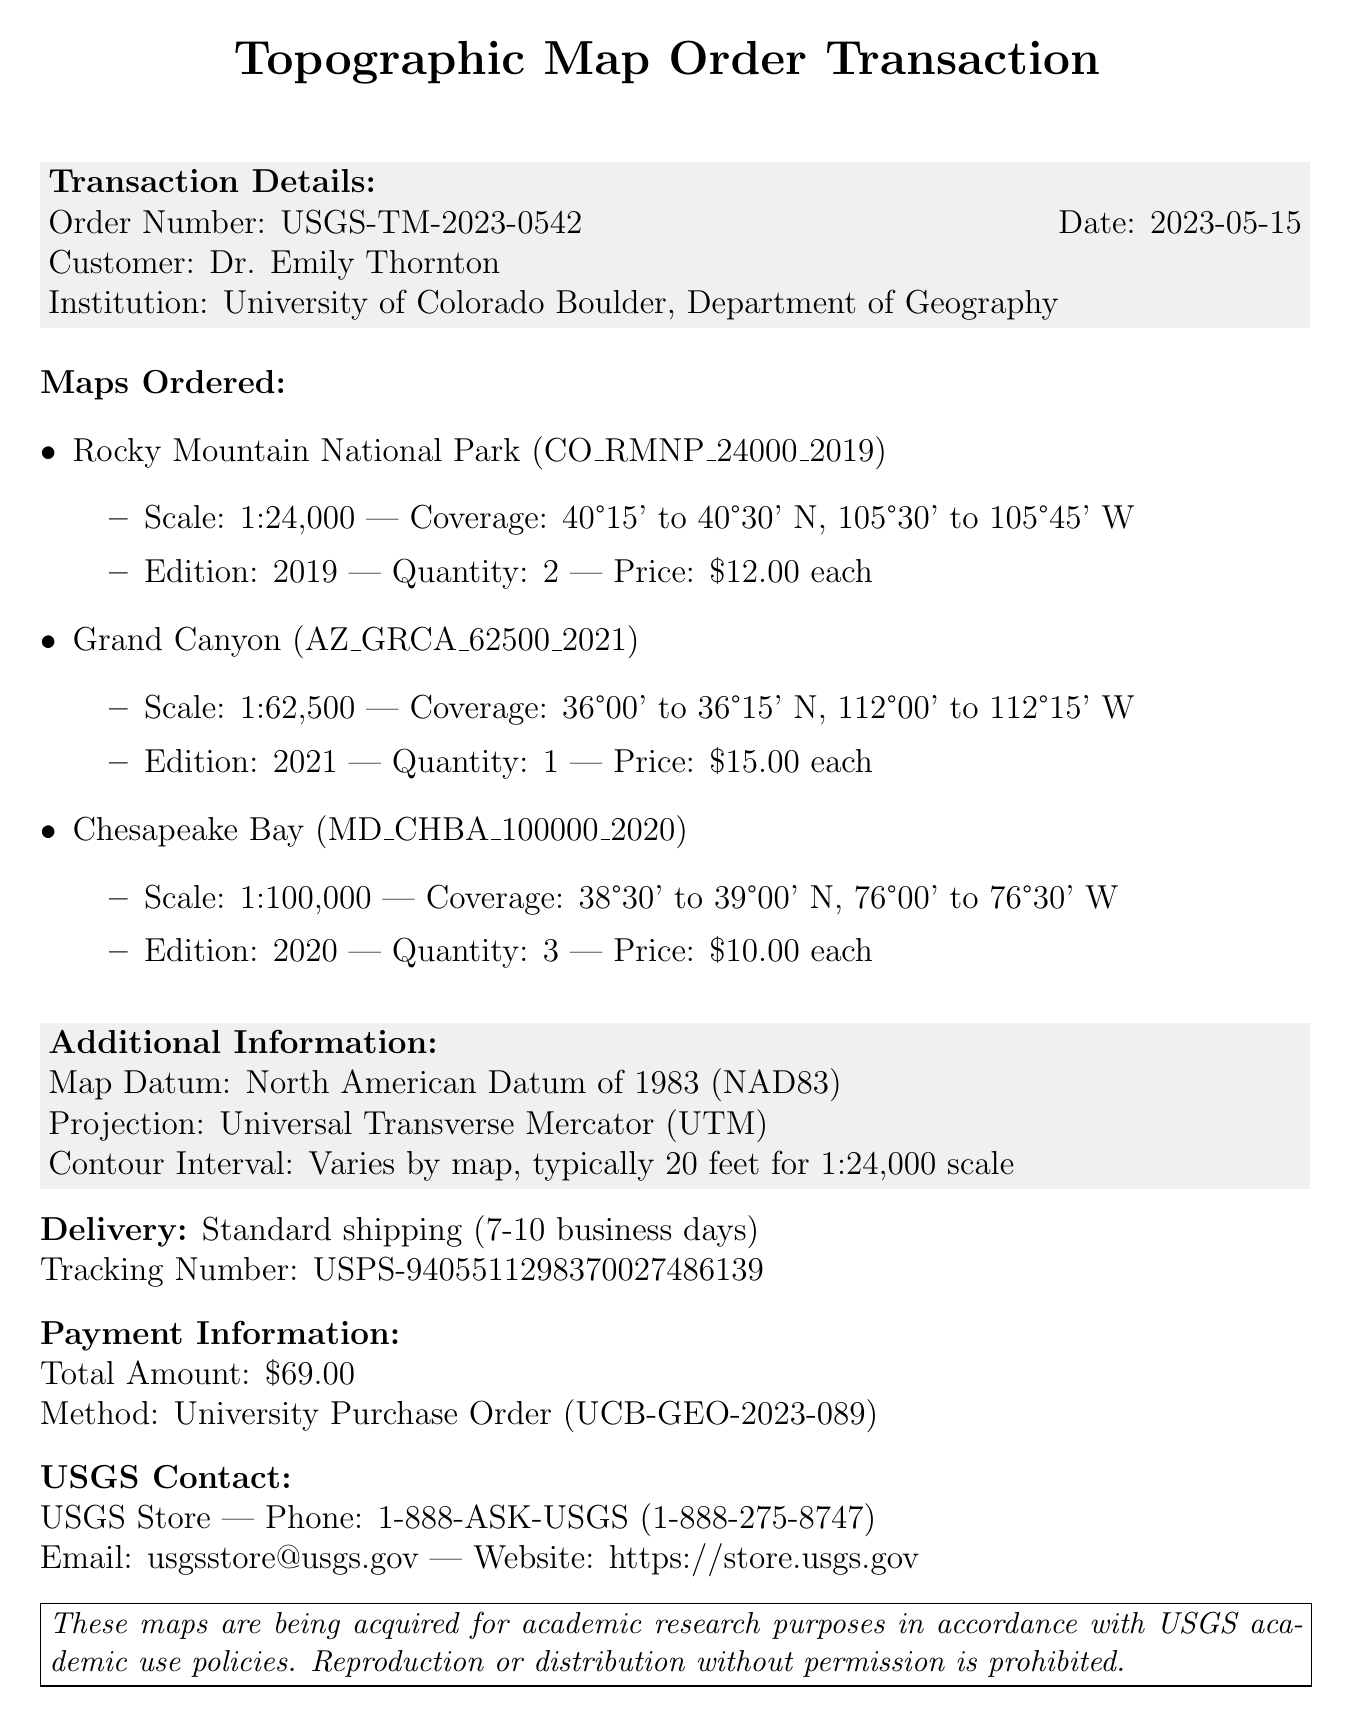What is the order number? The order number is a specific identifier for the transaction, found in the transaction details section.
Answer: USGS-TM-2023-0542 Who is the customer? The customer's name is provided in the transaction details section.
Answer: Dr. Emily Thornton What is the scale of the Chesapeake Bay map? The scale of the Chesapeake Bay map is listed in the details for that specific map.
Answer: 1:100,000 How many maps were ordered in total? The total number of maps can be found by summing the quantity of each map in the order.
Answer: 6 What is the total amount paid for the order? The total amount is specified in the payment information section.
Answer: $69.00 What is the estimated delivery time? The estimated delivery time is mentioned in the delivery method section of the document.
Answer: 7-10 business days What edition is the Grand Canyon map? The edition of the Grand Canyon map is mentioned in the details for that specific map.
Answer: 2021 What type of projection is used for the maps? The type of projection is stated in the additional information section.
Answer: Universal Transverse Mercator (UTM) 